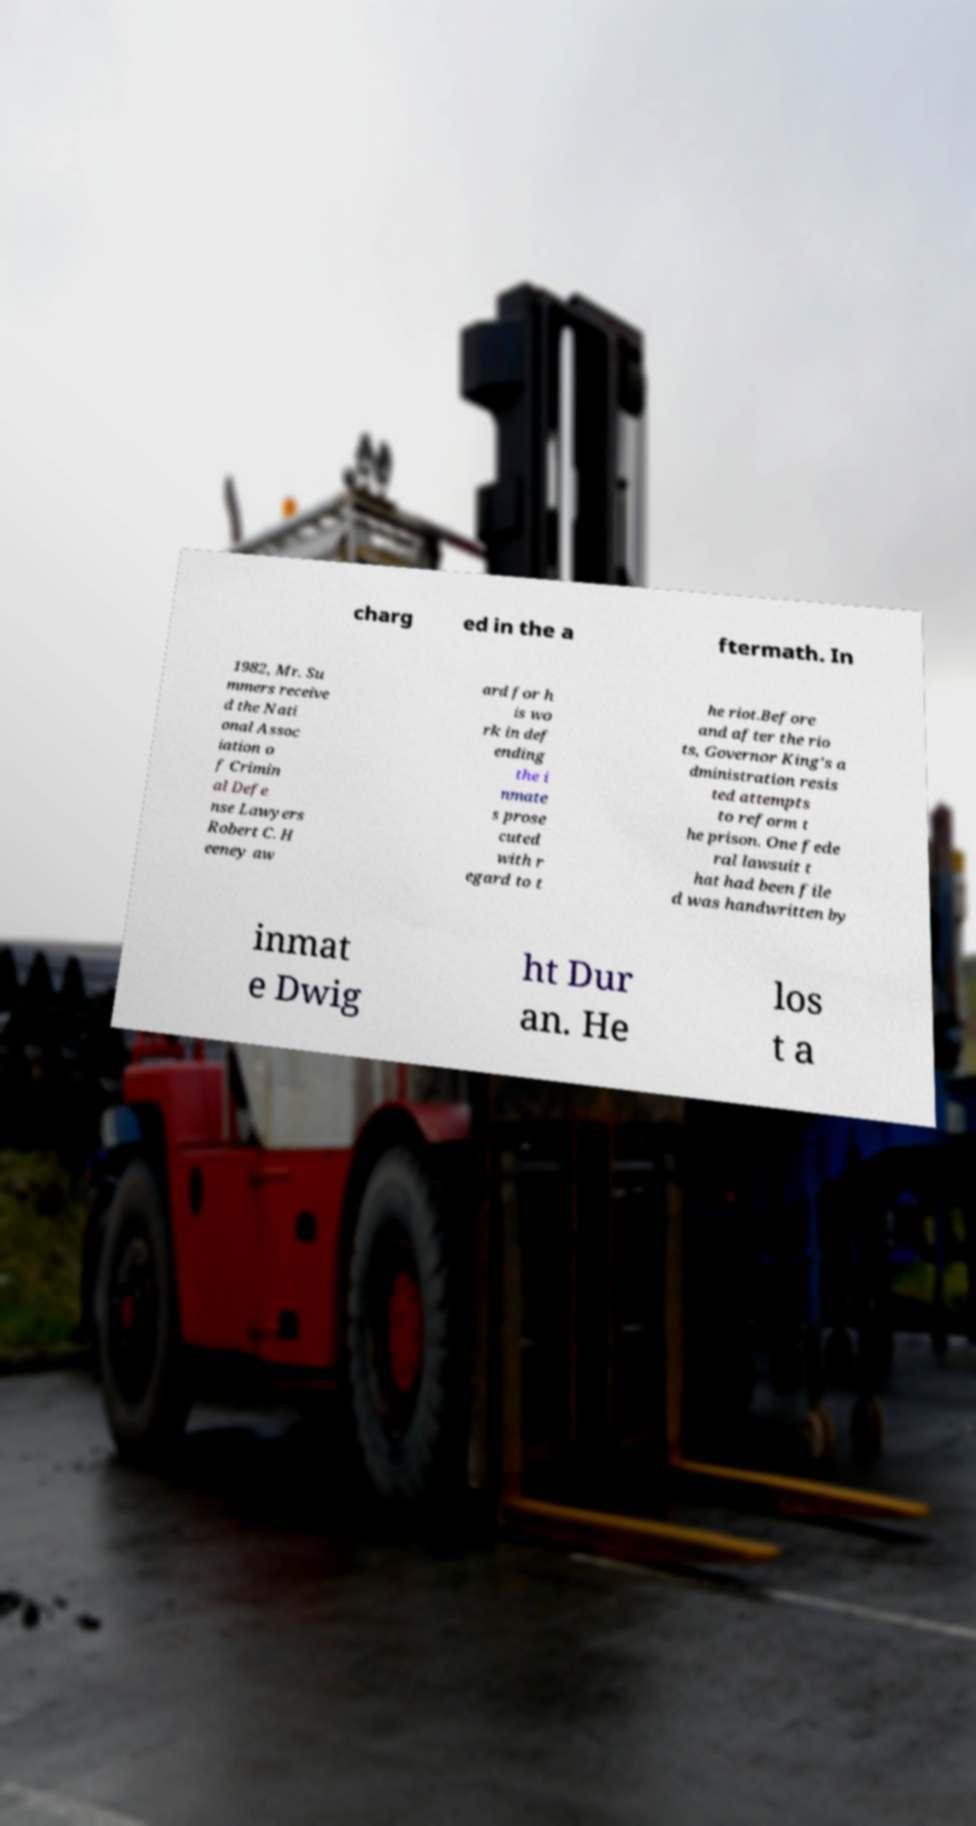There's text embedded in this image that I need extracted. Can you transcribe it verbatim? charg ed in the a ftermath. In 1982, Mr. Su mmers receive d the Nati onal Assoc iation o f Crimin al Defe nse Lawyers Robert C. H eeney aw ard for h is wo rk in def ending the i nmate s prose cuted with r egard to t he riot.Before and after the rio ts, Governor King's a dministration resis ted attempts to reform t he prison. One fede ral lawsuit t hat had been file d was handwritten by inmat e Dwig ht Dur an. He los t a 